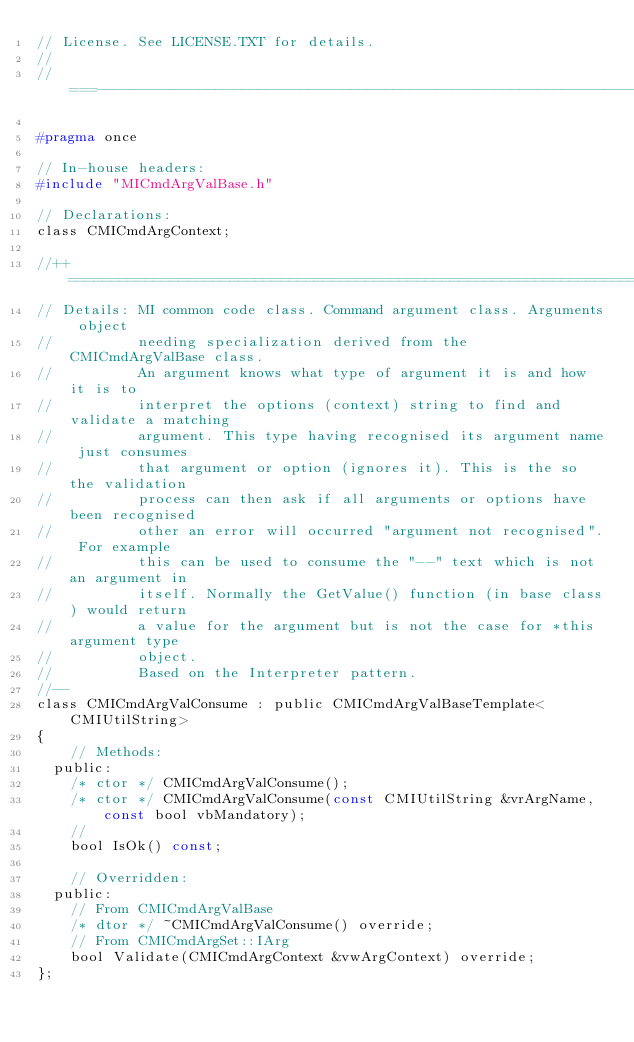Convert code to text. <code><loc_0><loc_0><loc_500><loc_500><_C_>// License. See LICENSE.TXT for details.
//
//===----------------------------------------------------------------------===//

#pragma once

// In-house headers:
#include "MICmdArgValBase.h"

// Declarations:
class CMICmdArgContext;

//++ ============================================================================
// Details: MI common code class. Command argument class. Arguments object
//          needing specialization derived from the CMICmdArgValBase class.
//          An argument knows what type of argument it is and how it is to
//          interpret the options (context) string to find and validate a matching
//          argument. This type having recognised its argument name just consumes
//          that argument or option (ignores it). This is the so the validation
//          process can then ask if all arguments or options have been recognised
//          other an error will occurred "argument not recognised". For example
//          this can be used to consume the "--" text which is not an argument in
//          itself. Normally the GetValue() function (in base class) would return
//          a value for the argument but is not the case for *this argument type
//          object.
//          Based on the Interpreter pattern.
//--
class CMICmdArgValConsume : public CMICmdArgValBaseTemplate<CMIUtilString>
{
    // Methods:
  public:
    /* ctor */ CMICmdArgValConsume();
    /* ctor */ CMICmdArgValConsume(const CMIUtilString &vrArgName, const bool vbMandatory);
    //
    bool IsOk() const;

    // Overridden:
  public:
    // From CMICmdArgValBase
    /* dtor */ ~CMICmdArgValConsume() override;
    // From CMICmdArgSet::IArg
    bool Validate(CMICmdArgContext &vwArgContext) override;
};
</code> 